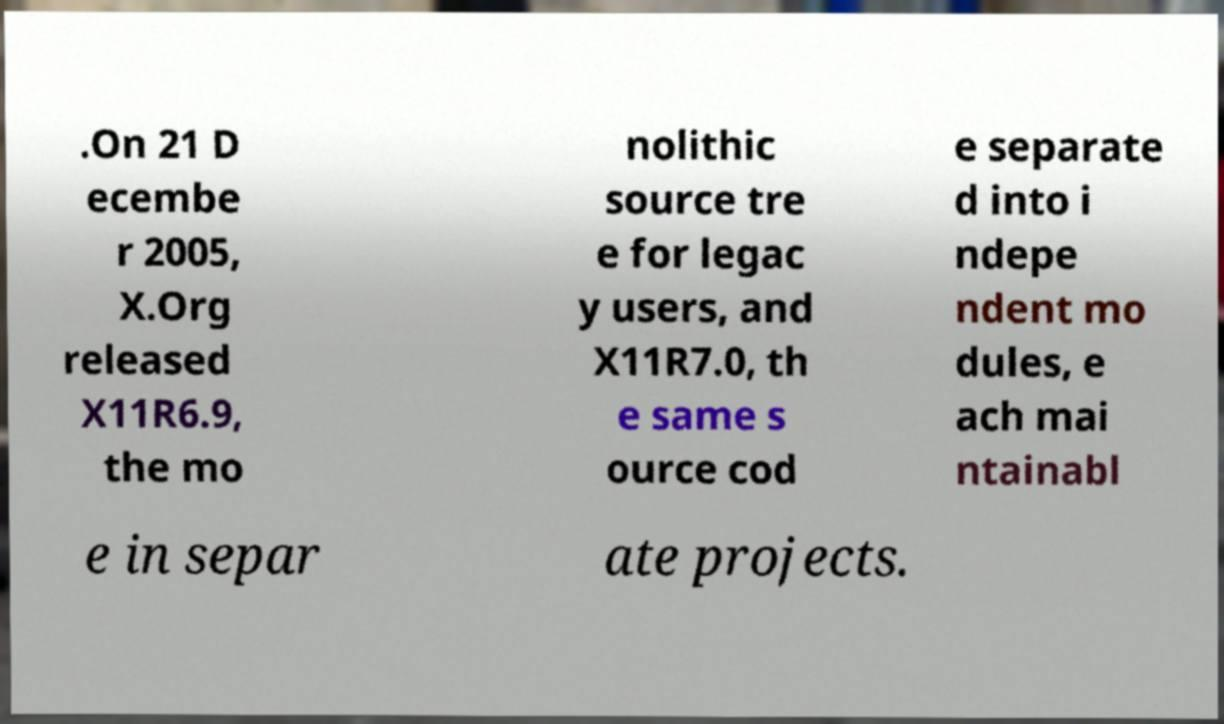What messages or text are displayed in this image? I need them in a readable, typed format. .On 21 D ecembe r 2005, X.Org released X11R6.9, the mo nolithic source tre e for legac y users, and X11R7.0, th e same s ource cod e separate d into i ndepe ndent mo dules, e ach mai ntainabl e in separ ate projects. 